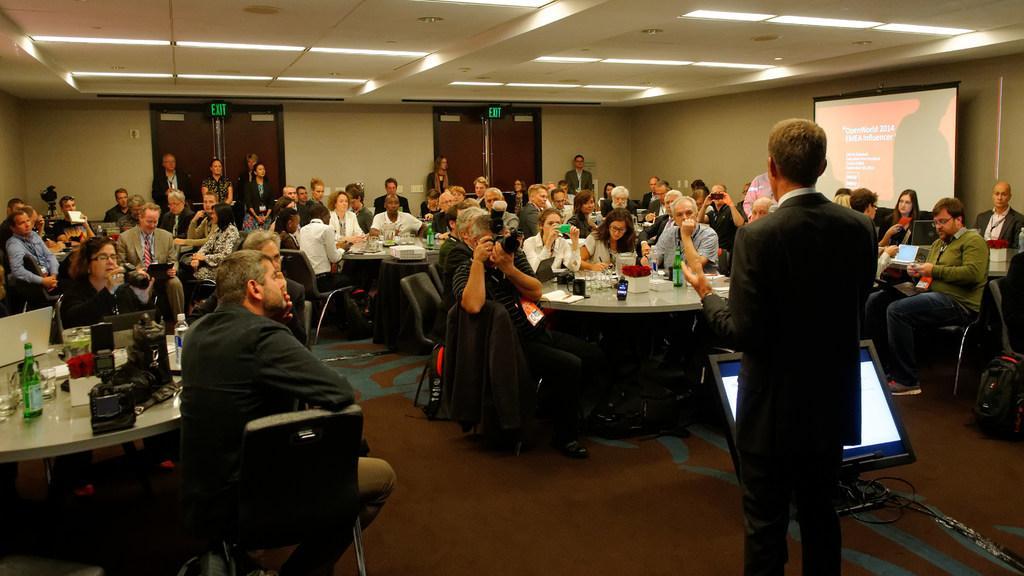Describe this image in one or two sentences. This is the picture of a room in which there are some people sitting on chairs around the table on which there are some bottles and some other things and to the side there is a screen and two doors. 